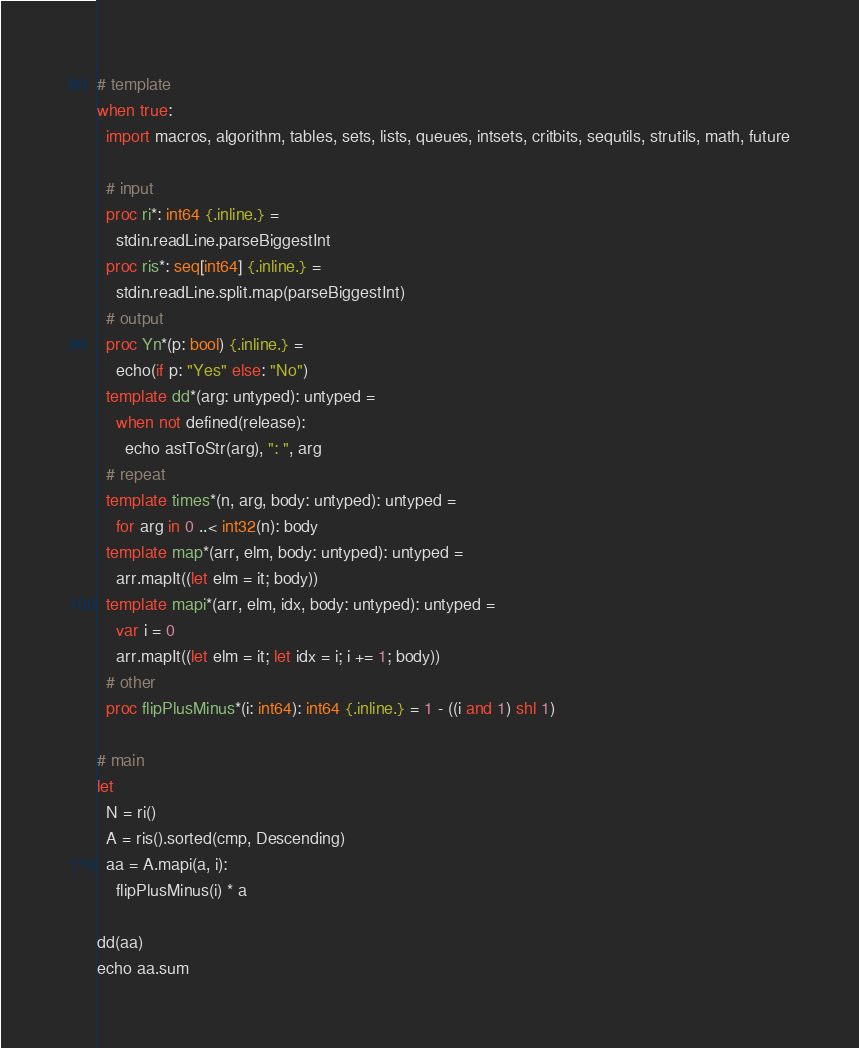Convert code to text. <code><loc_0><loc_0><loc_500><loc_500><_Nim_># template
when true:
  import macros, algorithm, tables, sets, lists, queues, intsets, critbits, sequtils, strutils, math, future

  # input
  proc ri*: int64 {.inline.} =
    stdin.readLine.parseBiggestInt
  proc ris*: seq[int64] {.inline.} =
    stdin.readLine.split.map(parseBiggestInt)
  # output
  proc Yn*(p: bool) {.inline.} =
    echo(if p: "Yes" else: "No")
  template dd*(arg: untyped): untyped =
    when not defined(release):
      echo astToStr(arg), ": ", arg
  # repeat
  template times*(n, arg, body: untyped): untyped =
    for arg in 0 ..< int32(n): body
  template map*(arr, elm, body: untyped): untyped =
    arr.mapIt((let elm = it; body))
  template mapi*(arr, elm, idx, body: untyped): untyped =
    var i = 0
    arr.mapIt((let elm = it; let idx = i; i += 1; body))
  # other
  proc flipPlusMinus*(i: int64): int64 {.inline.} = 1 - ((i and 1) shl 1)

# main
let
  N = ri()
  A = ris().sorted(cmp, Descending)
  aa = A.mapi(a, i):
    flipPlusMinus(i) * a

dd(aa)
echo aa.sum
</code> 